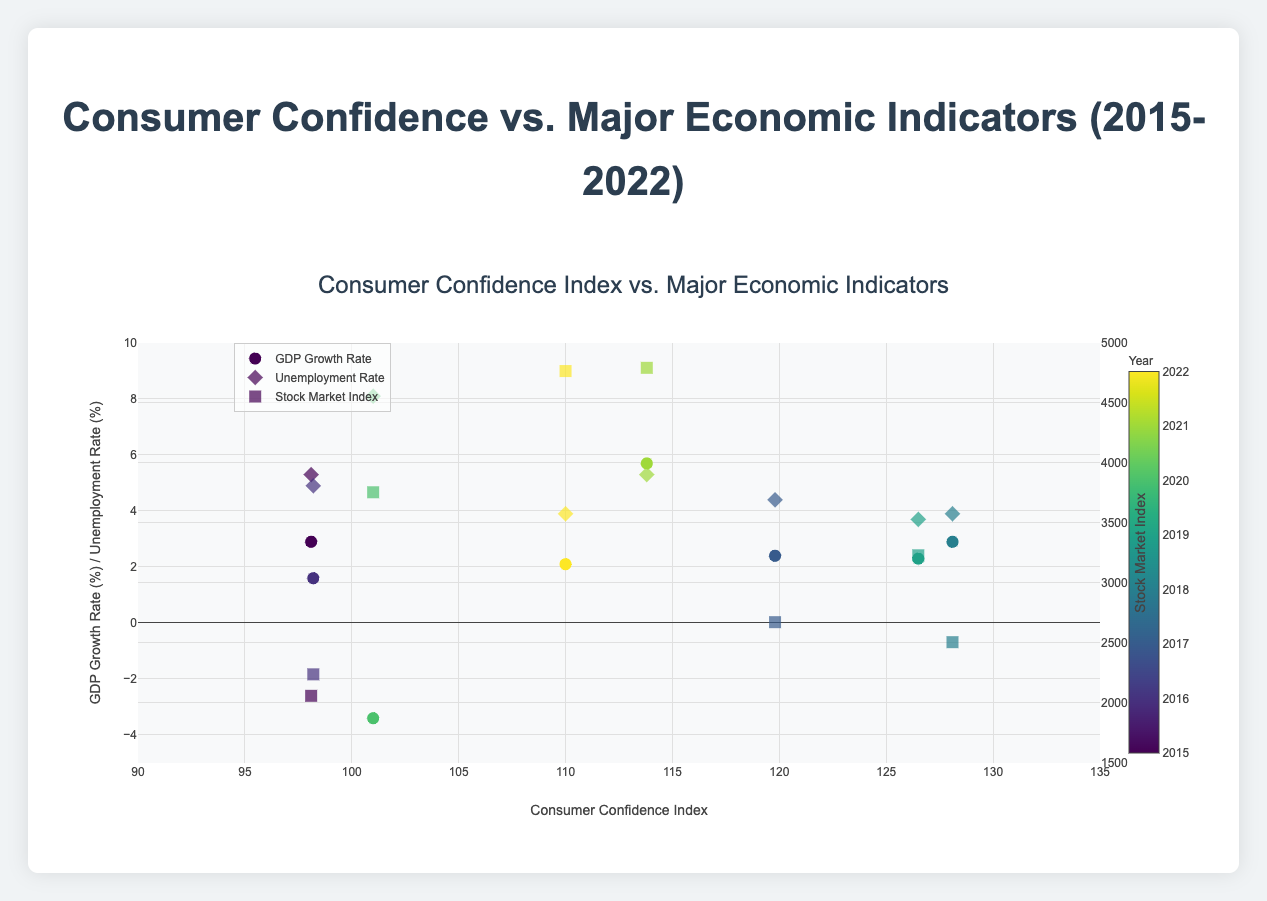what is the title of the plot? The title of the plot is displayed at the top center of the figure in a large font size. It directly indicates the subject of the plot, which is about the Consumer Confidence Index as it relates to Major Economic Indicators from 2015 to 2022.
Answer: Consumer Confidence vs. Major Economic Indicators (2015-2022) What is the range of the Consumer Confidence Index on the x-axis? The x-axis is labeled "Consumer Confidence Index," and the range is marked with tick values that span from 90 to 135. These tick values indicate the minimum and maximum range for the Consumer Confidence Index on the plot.
Answer: 90 to 135 Which year shows the lowest GDP Growth Rate, and what is its value? By examining the data points with their captions, we can identify the year corresponding to the lowest y-value in the series for the GDP Growth Rate. The year 2020 displays the lowest GDP Growth Rate, shown with a negative value in the hover information.
Answer: 2020 and -3.4% How many data points are there for the Unemployment Rate series? The Unemployment Rate series is shown with diamond markers. Counting these markers on the plot yields the total number of data points provided for the Unemployment Rate.
Answer: 8 Does higher Consumer Confidence correlate with a higher Stock Market Index? Observing the markers representing the Stock Market Index, higher values of the Stock Market Index generally appear at higher values of the Consumer Confidence Index on the x-axis. For example, the highest Stock Market Index value occurs in 2021 when the Consumer Confidence Index is relatively high.
Answer: Yes Which year had the highest Stock Market Index, and what was the Consumer Confidence Index that year? By looking at the square markers and their hover information, one marker with the highest y-value in the Stock Market Index series represents 2021. The Consumer Confidence Index for this year can be read from the x-coordinate of the marker.
Answer: 2021 and 113.8 Compare the years 2017 and 2018 in terms of GDP Growth Rate and Unemployment Rate. Which year performed better? To compare, look at the markers for both GDP Growth Rate and Unemployment Rate for the years 2017 and 2018. The hover information shows that 2018 had a GDP Growth Rate of 2.9% and Unemployment Rate of 3.9%, while 2017 had a GDP Growth Rate of 2.4% and Unemployment Rate of 4.4%. Combining both indicators shows that 2018 performed better with higher growth and lower unemployment.
Answer: 2018 performed better What is the trend observed in the Stock Market Index from 2015 to 2022? By following the series of square markers (Stock Market Index) and noting their y-values, we observe an increasing trend over the period from 2015 to 2022, particularly significant increases in later years like 2021.
Answer: Increasing trend How does the Unemployment Rate in 2020 compare to its rate in 2015? The Unemployment Rate in 2020 can be identified from the hover information as 8.1%. Similarly, the rate in 2015 is 5.3%. Comparing these values shows that the Unemployment Rate was higher in 2020 compared to 2015.
Answer: Higher in 2020 